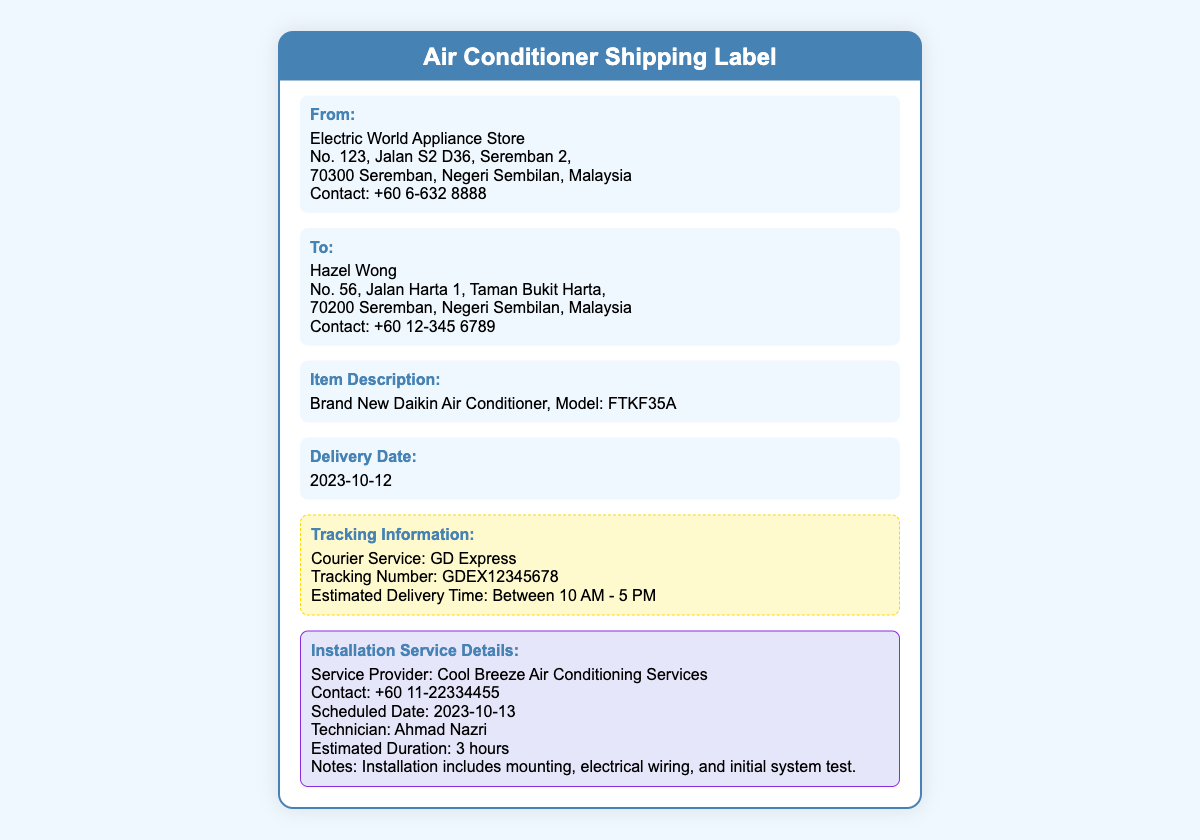what is the sender's name? The sender's name is listed in the document under the "From" section.
Answer: Electric World Appliance Store what is the recipient's phone number? The recipient's phone number can be found in the "To" section of the document.
Answer: +60 12-345 6789 what is the model of the air conditioner? The model of the air conditioner is specified in the Item Description section of the document.
Answer: FTKF35A what is the scheduled installation date? The installation date is provided in the Installation Service Details section of the document.
Answer: 2023-10-13 who is the technician for the installation? The technician's name is mentioned in the Installation Service Details section.
Answer: Ahmad Nazri what is the estimated duration of the installation? The estimated duration is included in the Installation Service Details section of the document.
Answer: 3 hours what courier service is being used for the shipment? The courier service is stated in the Tracking Information section of the document.
Answer: GD Express what is the delivery date for the air conditioner? The delivery date can be found in the document under the Delivery Date section.
Answer: 2023-10-12 what type of service is included in the installation? The type of service included is described under the Installation Service Details section.
Answer: Mounting, electrical wiring, and initial system test 